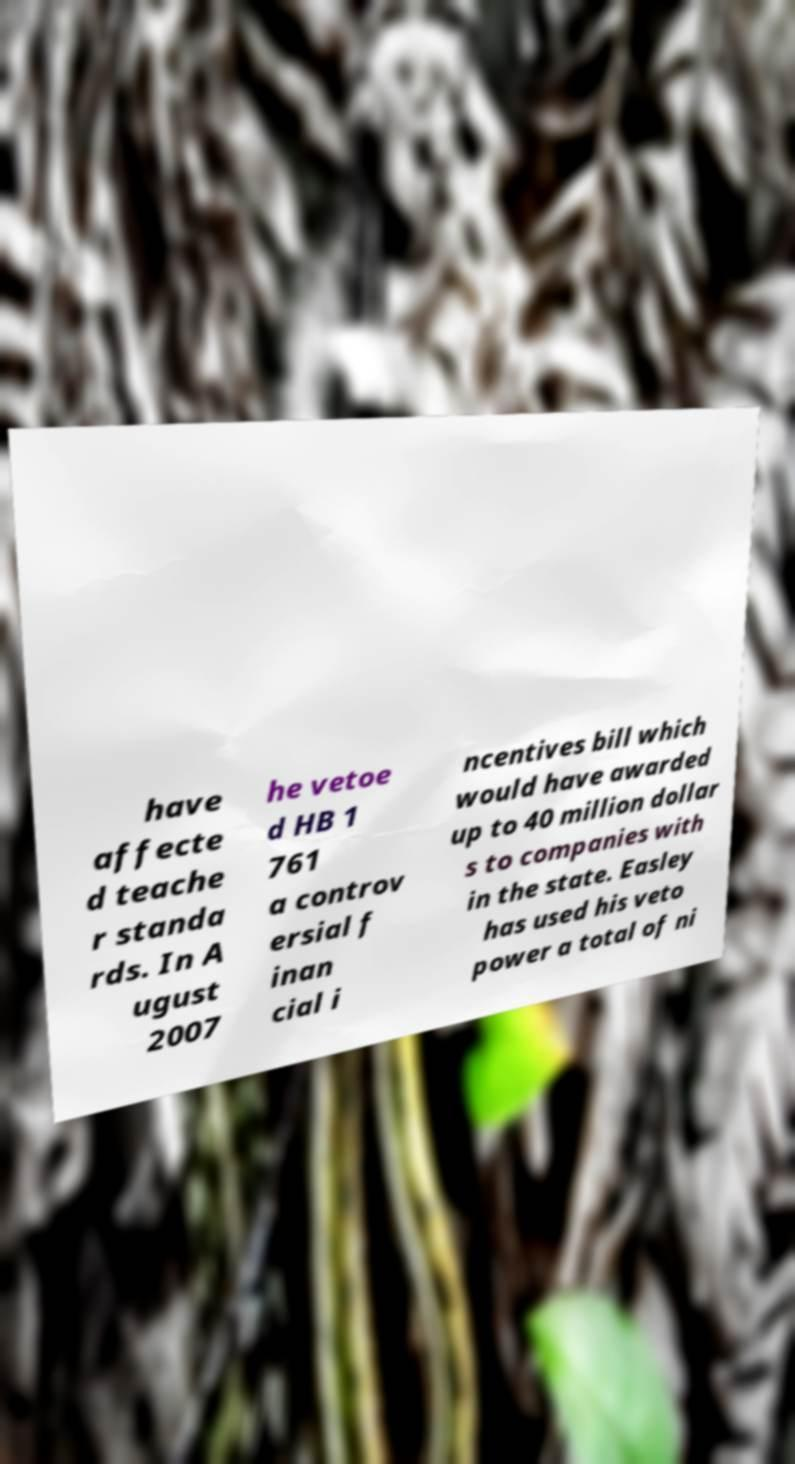What messages or text are displayed in this image? I need them in a readable, typed format. have affecte d teache r standa rds. In A ugust 2007 he vetoe d HB 1 761 a controv ersial f inan cial i ncentives bill which would have awarded up to 40 million dollar s to companies with in the state. Easley has used his veto power a total of ni 